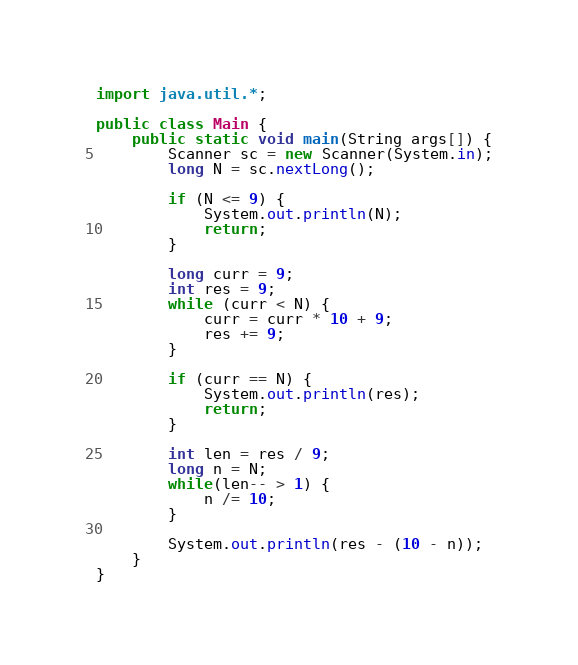Convert code to text. <code><loc_0><loc_0><loc_500><loc_500><_Java_>import java.util.*;

public class Main {
    public static void main(String args[]) {
        Scanner sc = new Scanner(System.in);
        long N = sc.nextLong();

        if (N <= 9) {
            System.out.println(N);
            return;
        }

        long curr = 9;
        int res = 9;
        while (curr < N) {
            curr = curr * 10 + 9;
            res += 9;
        }

        if (curr == N) {
            System.out.println(res);
            return;
        }

        int len = res / 9;
        long n = N;
        while(len-- > 1) {
            n /= 10;
        }

        System.out.println(res - (10 - n));
    }
}
</code> 